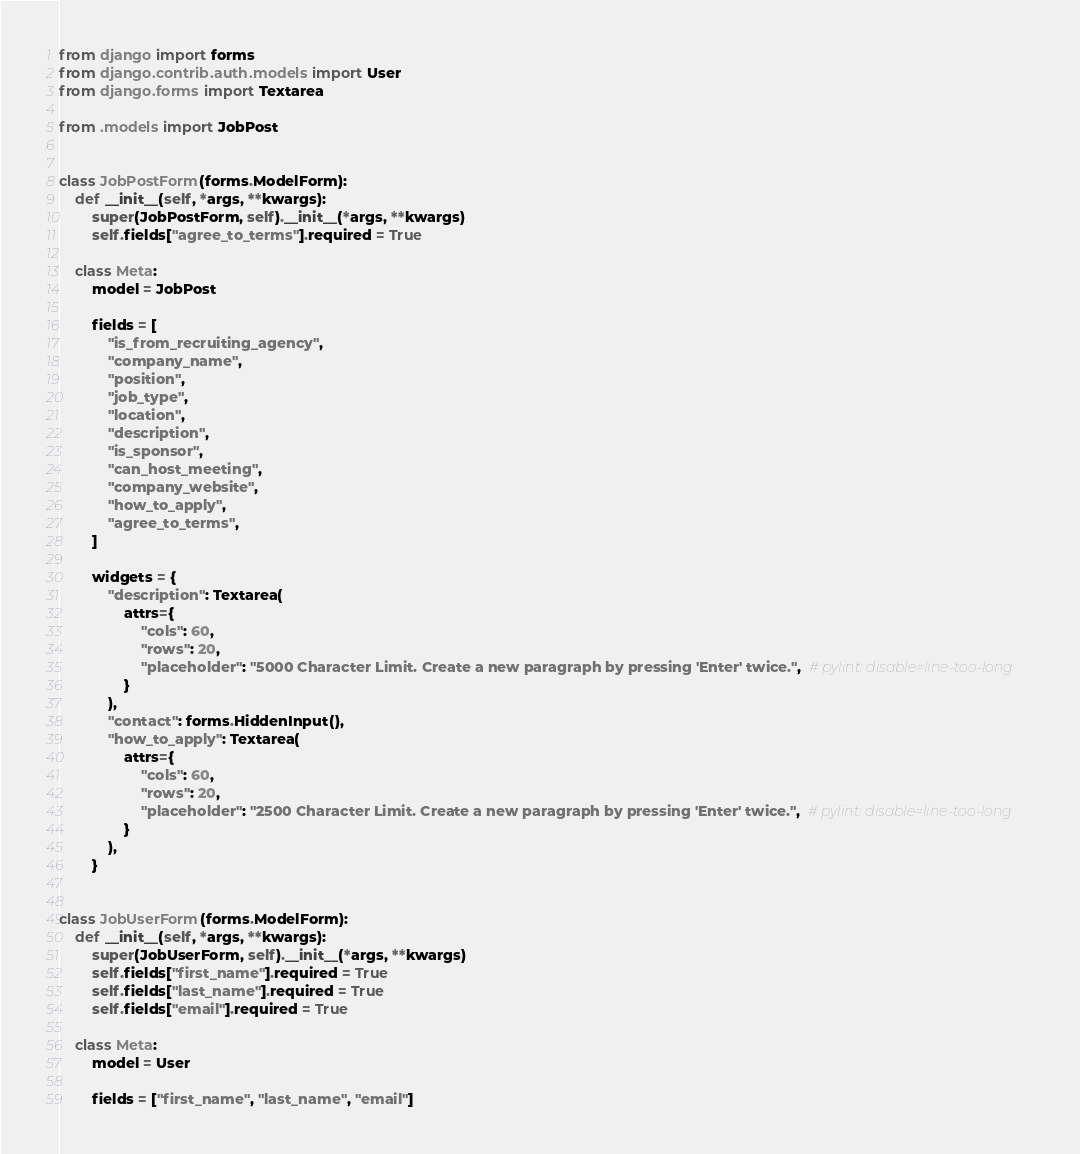<code> <loc_0><loc_0><loc_500><loc_500><_Python_>from django import forms
from django.contrib.auth.models import User
from django.forms import Textarea

from .models import JobPost


class JobPostForm(forms.ModelForm):
    def __init__(self, *args, **kwargs):
        super(JobPostForm, self).__init__(*args, **kwargs)
        self.fields["agree_to_terms"].required = True

    class Meta:
        model = JobPost

        fields = [
            "is_from_recruiting_agency",
            "company_name",
            "position",
            "job_type",
            "location",
            "description",
            "is_sponsor",
            "can_host_meeting",
            "company_website",
            "how_to_apply",
            "agree_to_terms",
        ]

        widgets = {
            "description": Textarea(
                attrs={
                    "cols": 60,
                    "rows": 20,
                    "placeholder": "5000 Character Limit. Create a new paragraph by pressing 'Enter' twice.",  # pylint: disable=line-too-long
                }
            ),
            "contact": forms.HiddenInput(),
            "how_to_apply": Textarea(
                attrs={
                    "cols": 60,
                    "rows": 20,
                    "placeholder": "2500 Character Limit. Create a new paragraph by pressing 'Enter' twice.",  # pylint: disable=line-too-long
                }
            ),
        }


class JobUserForm(forms.ModelForm):
    def __init__(self, *args, **kwargs):
        super(JobUserForm, self).__init__(*args, **kwargs)
        self.fields["first_name"].required = True
        self.fields["last_name"].required = True
        self.fields["email"].required = True

    class Meta:
        model = User

        fields = ["first_name", "last_name", "email"]
</code> 